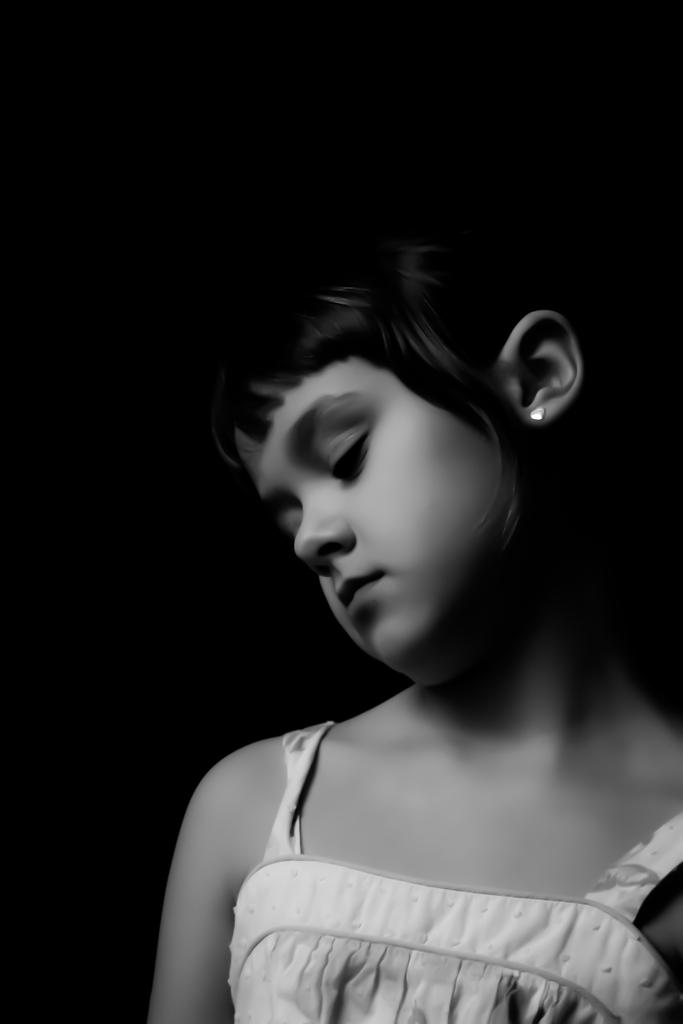Who is the main subject in the image? There is a girl in the image. What is the color scheme of the image? The image is black and white. What can be observed about the background of the image? The background of the image is completely dark. How many snakes are slithering around the girl in the image? There are no snakes present in the image; it features a girl in a black and white setting with a dark background. 